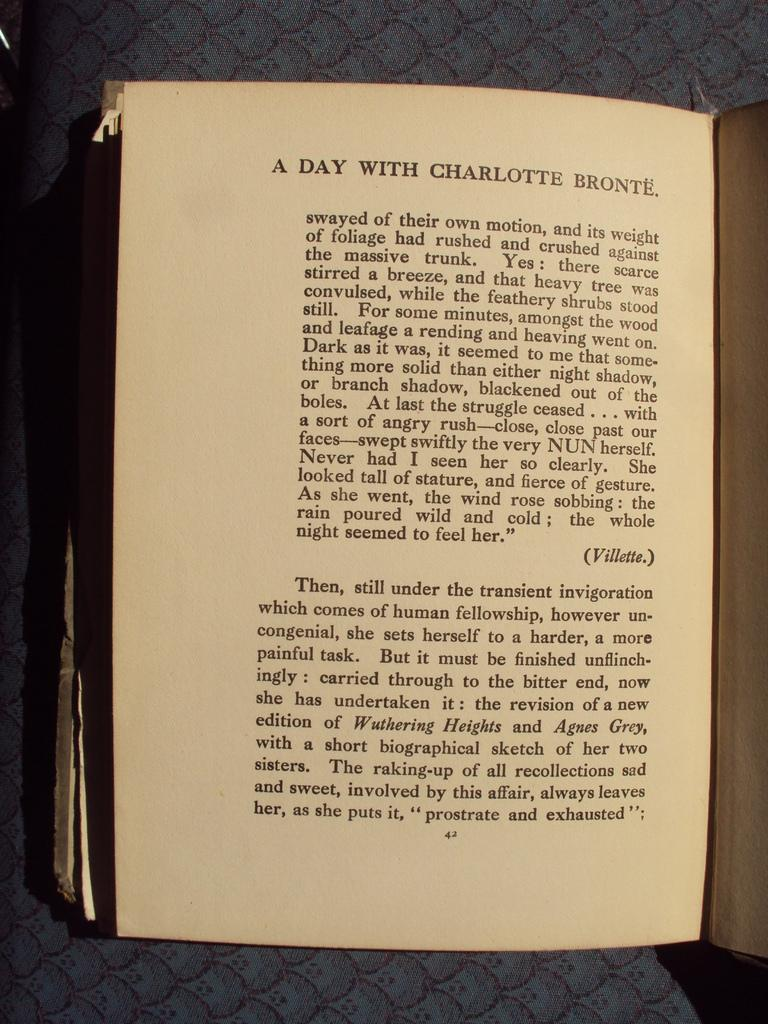Provide a one-sentence caption for the provided image. the 42 page of A day with Charlotte Bronte  book is displayed. 